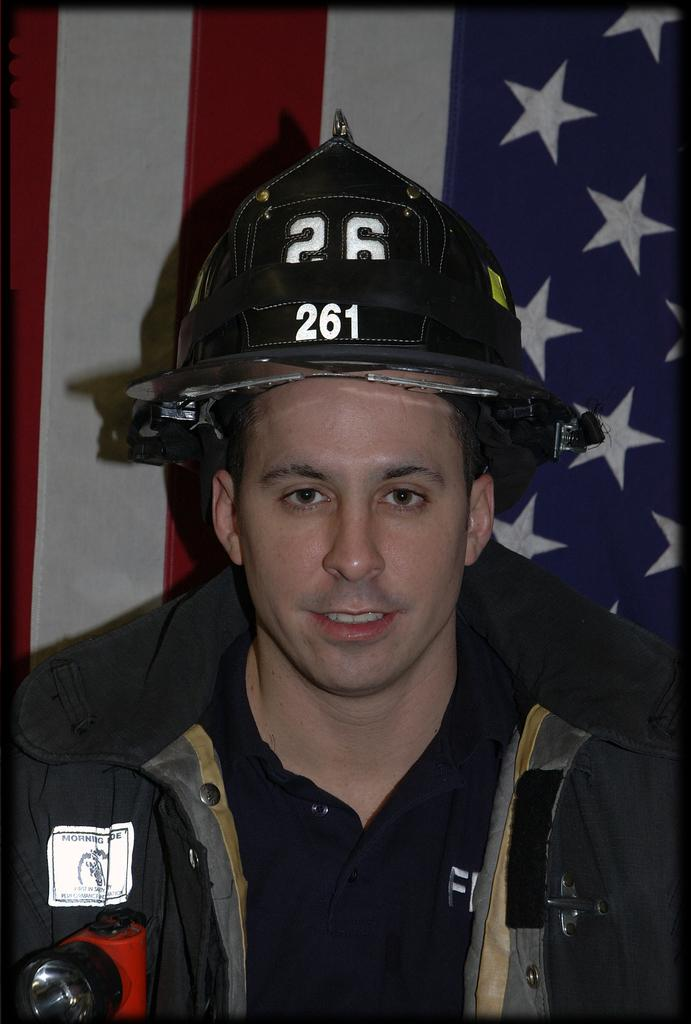Who is present in the image? There is a man in the image. What is the man wearing on his head? The man is wearing a helmet. What can be seen in the background of the image? There is a USA flag in the background of the image. What is the price of the jam in the image? There is no jam present in the image, so it is not possible to determine its price. 